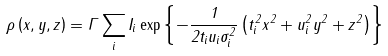<formula> <loc_0><loc_0><loc_500><loc_500>\rho \left ( x , y , z \right ) = \Gamma \sum _ { i } I _ { i } \exp { \left \{ - \frac { 1 } { 2 t _ { i } u _ { i } \sigma _ { i } ^ { 2 } } \left ( t _ { i } ^ { 2 } x ^ { 2 } + u _ { i } ^ { 2 } y ^ { 2 } + z ^ { 2 } \right ) \right \} }</formula> 